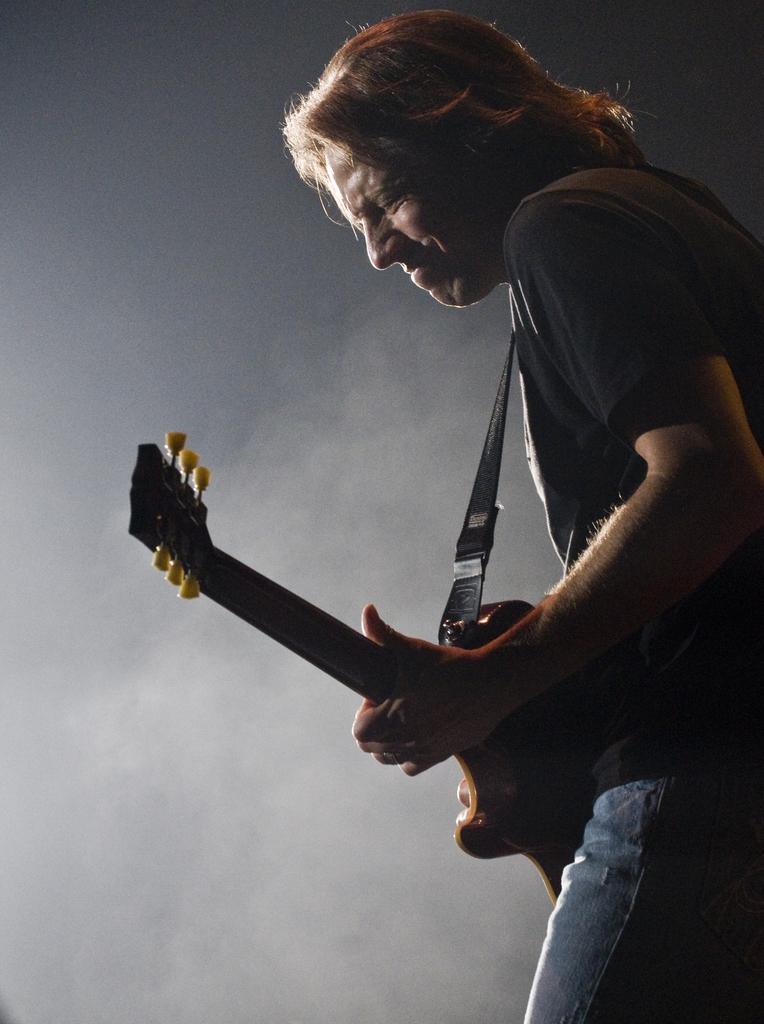In one or two sentences, can you explain what this image depicts? Here we can see a person playing a guitar 